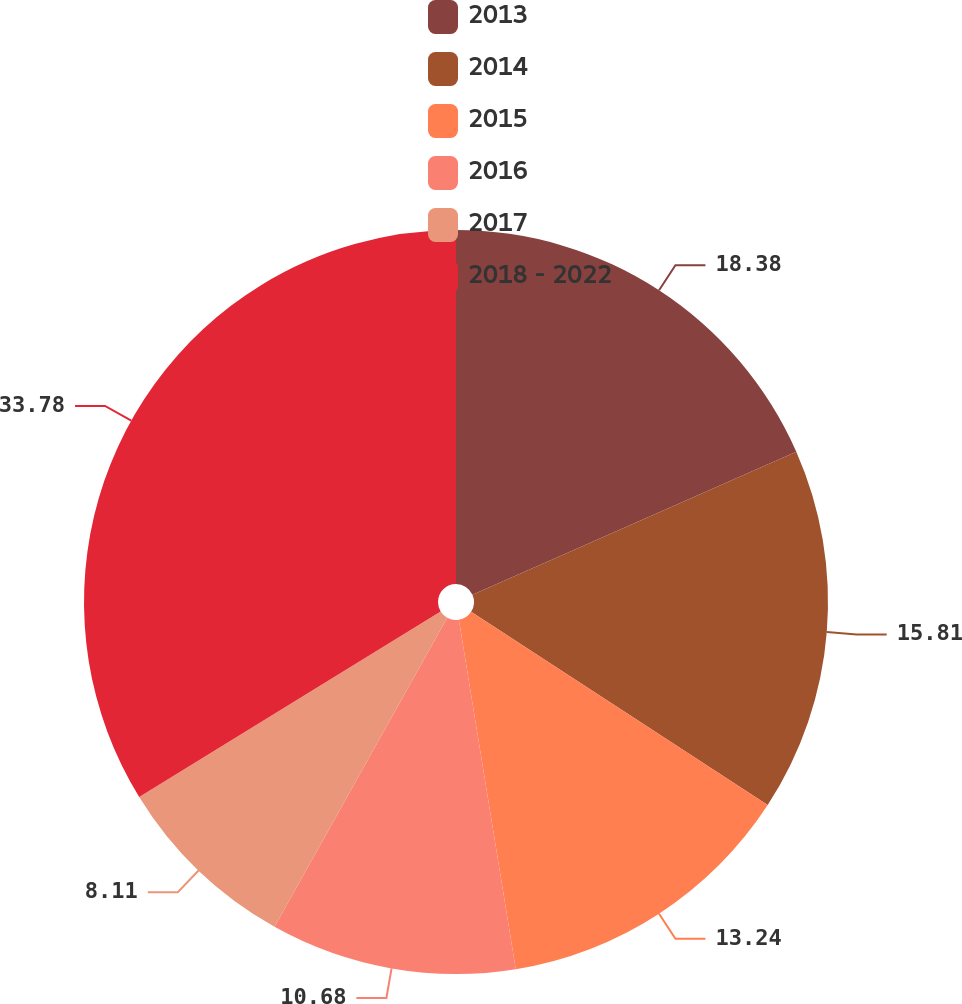Convert chart. <chart><loc_0><loc_0><loc_500><loc_500><pie_chart><fcel>2013<fcel>2014<fcel>2015<fcel>2016<fcel>2017<fcel>2018 - 2022<nl><fcel>18.38%<fcel>15.81%<fcel>13.24%<fcel>10.68%<fcel>8.11%<fcel>33.78%<nl></chart> 